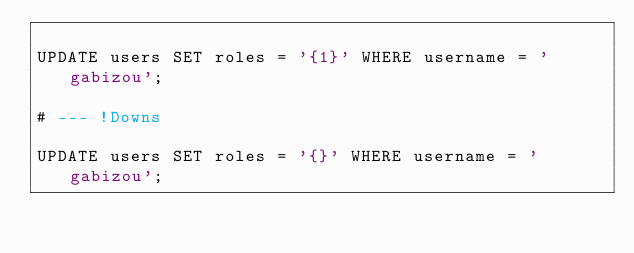<code> <loc_0><loc_0><loc_500><loc_500><_SQL_>
UPDATE users SET roles = '{1}' WHERE username = 'gabizou';

# --- !Downs

UPDATE users SET roles = '{}' WHERE username = 'gabizou';
</code> 